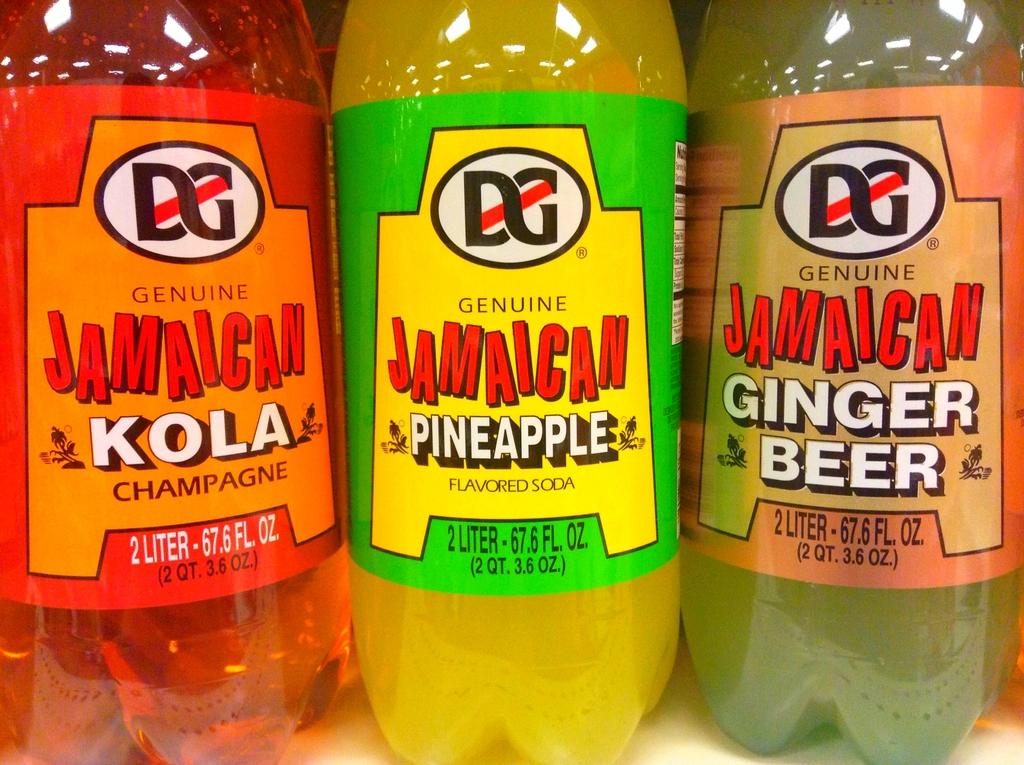<image>
Relay a brief, clear account of the picture shown. Three plastic bottles of Jamaican drinks by DG. 